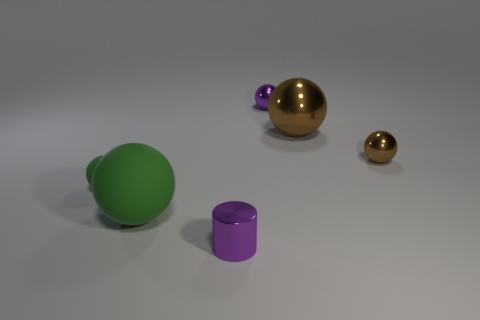Subtract all cyan balls. Subtract all green cylinders. How many balls are left? 5 Add 3 big brown metallic spheres. How many objects exist? 9 Subtract all cylinders. How many objects are left? 5 Subtract 0 cyan spheres. How many objects are left? 6 Subtract all tiny purple matte blocks. Subtract all brown objects. How many objects are left? 4 Add 6 small shiny things. How many small shiny things are left? 9 Add 2 large rubber things. How many large rubber things exist? 3 